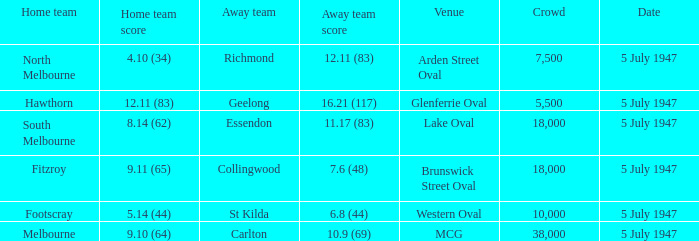Where was the game played where the away team has a score of 7.6 (48)? Brunswick Street Oval. 